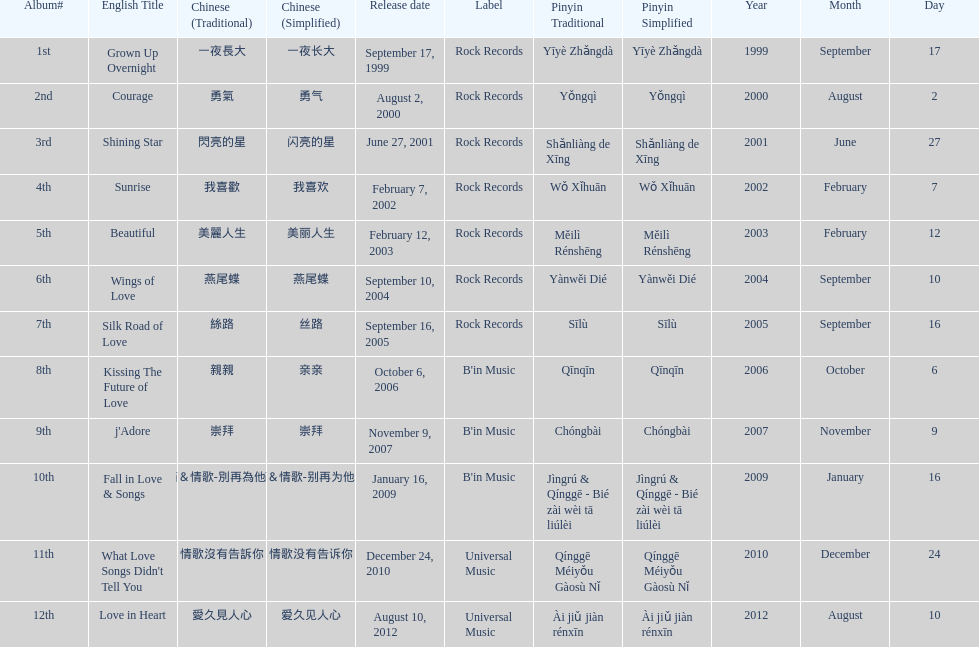I'm looking to parse the entire table for insights. Could you assist me with that? {'header': ['Album#', 'English Title', 'Chinese (Traditional)', 'Chinese (Simplified)', 'Release date', 'Label', 'Pinyin Traditional', 'Pinyin Simplified', 'Year', 'Month', 'Day'], 'rows': [['1st', 'Grown Up Overnight', '一夜長大', '一夜长大', 'September 17, 1999', 'Rock Records', 'Yīyè Zhǎngdà', 'Yīyè Zhǎngdà', '1999', 'September', '17'], ['2nd', 'Courage', '勇氣', '勇气', 'August 2, 2000', 'Rock Records', 'Yǒngqì', 'Yǒngqì', '2000', 'August', '2'], ['3rd', 'Shining Star', '閃亮的星', '闪亮的星', 'June 27, 2001', 'Rock Records', 'Shǎnliàng de Xīng', 'Shǎnliàng de Xīng', '2001', 'June', '27'], ['4th', 'Sunrise', '我喜歡', '我喜欢', 'February 7, 2002', 'Rock Records', 'Wǒ Xǐhuān', 'Wǒ Xǐhuān', '2002', 'February', '7'], ['5th', 'Beautiful', '美麗人生', '美丽人生', 'February 12, 2003', 'Rock Records', 'Měilì Rénshēng', 'Měilì Rénshēng', '2003', 'February', '12'], ['6th', 'Wings of Love', '燕尾蝶', '燕尾蝶', 'September 10, 2004', 'Rock Records', 'Yànwěi Dié', 'Yànwěi Dié', '2004', 'September', '10'], ['7th', 'Silk Road of Love', '絲路', '丝路', 'September 16, 2005', 'Rock Records', 'Sīlù', 'Sīlù', '2005', 'September', '16'], ['8th', 'Kissing The Future of Love', '親親', '亲亲', 'October 6, 2006', "B'in Music", 'Qīnqīn', 'Qīnqīn', '2006', 'October', '6'], ['9th', "j'Adore", '崇拜', '崇拜', 'November 9, 2007', "B'in Music", 'Chóngbài', 'Chóngbài', '2007', 'November', '9'], ['10th', 'Fall in Love & Songs', '靜茹＆情歌-別再為他流淚', '静茹＆情歌-别再为他流泪', 'January 16, 2009', "B'in Music", 'Jìngrú & Qínggē - Bié zài wèi tā liúlèi', 'Jìngrú & Qínggē - Bié zài wèi tā liúlèi', '2009', 'January', '16'], ['11th', "What Love Songs Didn't Tell You", '情歌沒有告訴你', '情歌没有告诉你', 'December 24, 2010', 'Universal Music', 'Qínggē Méiyǒu Gàosù Nǐ', 'Qínggē Méiyǒu Gàosù Nǐ', '2010', 'December', '24'], ['12th', 'Love in Heart', '愛久見人心', '爱久见人心', 'August 10, 2012', 'Universal Music', 'Ài jiǔ jiàn rénxīn', 'Ài jiǔ jiàn rénxīn', '2012', 'August', '10']]} What is the number of songs on rock records? 7. 